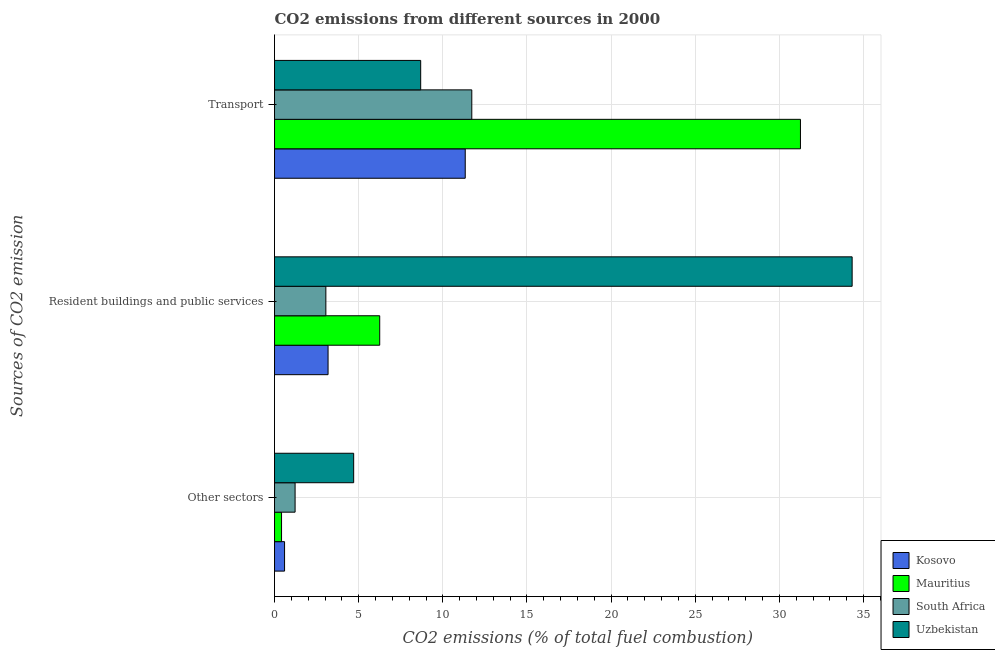How many different coloured bars are there?
Your answer should be very brief. 4. How many groups of bars are there?
Your answer should be very brief. 3. What is the label of the 3rd group of bars from the top?
Make the answer very short. Other sectors. What is the percentage of co2 emissions from transport in Uzbekistan?
Ensure brevity in your answer.  8.68. Across all countries, what is the maximum percentage of co2 emissions from transport?
Make the answer very short. 31.25. Across all countries, what is the minimum percentage of co2 emissions from transport?
Provide a short and direct response. 8.68. In which country was the percentage of co2 emissions from transport maximum?
Your response must be concise. Mauritius. In which country was the percentage of co2 emissions from transport minimum?
Offer a terse response. Uzbekistan. What is the total percentage of co2 emissions from other sectors in the graph?
Provide a succinct answer. 6.94. What is the difference between the percentage of co2 emissions from other sectors in Uzbekistan and that in Mauritius?
Give a very brief answer. 4.29. What is the difference between the percentage of co2 emissions from resident buildings and public services in Mauritius and the percentage of co2 emissions from other sectors in Kosovo?
Give a very brief answer. 5.65. What is the average percentage of co2 emissions from resident buildings and public services per country?
Give a very brief answer. 11.7. What is the difference between the percentage of co2 emissions from other sectors and percentage of co2 emissions from transport in South Africa?
Provide a short and direct response. -10.5. In how many countries, is the percentage of co2 emissions from other sectors greater than 18 %?
Make the answer very short. 0. What is the ratio of the percentage of co2 emissions from resident buildings and public services in Kosovo to that in Uzbekistan?
Give a very brief answer. 0.09. What is the difference between the highest and the second highest percentage of co2 emissions from resident buildings and public services?
Your response must be concise. 28.07. What is the difference between the highest and the lowest percentage of co2 emissions from transport?
Ensure brevity in your answer.  22.57. In how many countries, is the percentage of co2 emissions from other sectors greater than the average percentage of co2 emissions from other sectors taken over all countries?
Make the answer very short. 1. Is the sum of the percentage of co2 emissions from resident buildings and public services in Kosovo and South Africa greater than the maximum percentage of co2 emissions from transport across all countries?
Keep it short and to the point. No. What does the 1st bar from the top in Resident buildings and public services represents?
Provide a succinct answer. Uzbekistan. What does the 3rd bar from the bottom in Resident buildings and public services represents?
Keep it short and to the point. South Africa. Is it the case that in every country, the sum of the percentage of co2 emissions from other sectors and percentage of co2 emissions from resident buildings and public services is greater than the percentage of co2 emissions from transport?
Ensure brevity in your answer.  No. How many countries are there in the graph?
Give a very brief answer. 4. What is the difference between two consecutive major ticks on the X-axis?
Offer a terse response. 5. How many legend labels are there?
Provide a succinct answer. 4. How are the legend labels stacked?
Your answer should be very brief. Vertical. What is the title of the graph?
Give a very brief answer. CO2 emissions from different sources in 2000. What is the label or title of the X-axis?
Ensure brevity in your answer.  CO2 emissions (% of total fuel combustion). What is the label or title of the Y-axis?
Give a very brief answer. Sources of CO2 emission. What is the CO2 emissions (% of total fuel combustion) of Kosovo in Other sectors?
Make the answer very short. 0.6. What is the CO2 emissions (% of total fuel combustion) of Mauritius in Other sectors?
Your answer should be very brief. 0.42. What is the CO2 emissions (% of total fuel combustion) of South Africa in Other sectors?
Offer a terse response. 1.22. What is the CO2 emissions (% of total fuel combustion) of Uzbekistan in Other sectors?
Make the answer very short. 4.7. What is the CO2 emissions (% of total fuel combustion) in Kosovo in Resident buildings and public services?
Provide a succinct answer. 3.18. What is the CO2 emissions (% of total fuel combustion) in Mauritius in Resident buildings and public services?
Keep it short and to the point. 6.25. What is the CO2 emissions (% of total fuel combustion) of South Africa in Resident buildings and public services?
Make the answer very short. 3.05. What is the CO2 emissions (% of total fuel combustion) in Uzbekistan in Resident buildings and public services?
Your answer should be very brief. 34.32. What is the CO2 emissions (% of total fuel combustion) in Kosovo in Transport?
Your response must be concise. 11.33. What is the CO2 emissions (% of total fuel combustion) of Mauritius in Transport?
Provide a short and direct response. 31.25. What is the CO2 emissions (% of total fuel combustion) in South Africa in Transport?
Provide a short and direct response. 11.72. What is the CO2 emissions (% of total fuel combustion) of Uzbekistan in Transport?
Offer a terse response. 8.68. Across all Sources of CO2 emission, what is the maximum CO2 emissions (% of total fuel combustion) in Kosovo?
Keep it short and to the point. 11.33. Across all Sources of CO2 emission, what is the maximum CO2 emissions (% of total fuel combustion) of Mauritius?
Your answer should be very brief. 31.25. Across all Sources of CO2 emission, what is the maximum CO2 emissions (% of total fuel combustion) in South Africa?
Give a very brief answer. 11.72. Across all Sources of CO2 emission, what is the maximum CO2 emissions (% of total fuel combustion) of Uzbekistan?
Your response must be concise. 34.32. Across all Sources of CO2 emission, what is the minimum CO2 emissions (% of total fuel combustion) of Kosovo?
Provide a short and direct response. 0.6. Across all Sources of CO2 emission, what is the minimum CO2 emissions (% of total fuel combustion) of Mauritius?
Your response must be concise. 0.42. Across all Sources of CO2 emission, what is the minimum CO2 emissions (% of total fuel combustion) of South Africa?
Offer a very short reply. 1.22. Across all Sources of CO2 emission, what is the minimum CO2 emissions (% of total fuel combustion) of Uzbekistan?
Make the answer very short. 4.7. What is the total CO2 emissions (% of total fuel combustion) of Kosovo in the graph?
Ensure brevity in your answer.  15.11. What is the total CO2 emissions (% of total fuel combustion) of Mauritius in the graph?
Offer a terse response. 37.92. What is the total CO2 emissions (% of total fuel combustion) of South Africa in the graph?
Provide a short and direct response. 15.99. What is the total CO2 emissions (% of total fuel combustion) of Uzbekistan in the graph?
Your answer should be very brief. 47.71. What is the difference between the CO2 emissions (% of total fuel combustion) of Kosovo in Other sectors and that in Resident buildings and public services?
Offer a terse response. -2.58. What is the difference between the CO2 emissions (% of total fuel combustion) in Mauritius in Other sectors and that in Resident buildings and public services?
Make the answer very short. -5.83. What is the difference between the CO2 emissions (% of total fuel combustion) of South Africa in Other sectors and that in Resident buildings and public services?
Provide a succinct answer. -1.83. What is the difference between the CO2 emissions (% of total fuel combustion) in Uzbekistan in Other sectors and that in Resident buildings and public services?
Offer a very short reply. -29.62. What is the difference between the CO2 emissions (% of total fuel combustion) in Kosovo in Other sectors and that in Transport?
Provide a succinct answer. -10.74. What is the difference between the CO2 emissions (% of total fuel combustion) in Mauritius in Other sectors and that in Transport?
Your response must be concise. -30.83. What is the difference between the CO2 emissions (% of total fuel combustion) of South Africa in Other sectors and that in Transport?
Your answer should be compact. -10.5. What is the difference between the CO2 emissions (% of total fuel combustion) in Uzbekistan in Other sectors and that in Transport?
Your answer should be compact. -3.98. What is the difference between the CO2 emissions (% of total fuel combustion) of Kosovo in Resident buildings and public services and that in Transport?
Provide a short and direct response. -8.15. What is the difference between the CO2 emissions (% of total fuel combustion) in South Africa in Resident buildings and public services and that in Transport?
Keep it short and to the point. -8.67. What is the difference between the CO2 emissions (% of total fuel combustion) of Uzbekistan in Resident buildings and public services and that in Transport?
Provide a succinct answer. 25.64. What is the difference between the CO2 emissions (% of total fuel combustion) in Kosovo in Other sectors and the CO2 emissions (% of total fuel combustion) in Mauritius in Resident buildings and public services?
Your answer should be compact. -5.65. What is the difference between the CO2 emissions (% of total fuel combustion) of Kosovo in Other sectors and the CO2 emissions (% of total fuel combustion) of South Africa in Resident buildings and public services?
Offer a terse response. -2.45. What is the difference between the CO2 emissions (% of total fuel combustion) of Kosovo in Other sectors and the CO2 emissions (% of total fuel combustion) of Uzbekistan in Resident buildings and public services?
Your response must be concise. -33.73. What is the difference between the CO2 emissions (% of total fuel combustion) of Mauritius in Other sectors and the CO2 emissions (% of total fuel combustion) of South Africa in Resident buildings and public services?
Your response must be concise. -2.63. What is the difference between the CO2 emissions (% of total fuel combustion) in Mauritius in Other sectors and the CO2 emissions (% of total fuel combustion) in Uzbekistan in Resident buildings and public services?
Give a very brief answer. -33.91. What is the difference between the CO2 emissions (% of total fuel combustion) in South Africa in Other sectors and the CO2 emissions (% of total fuel combustion) in Uzbekistan in Resident buildings and public services?
Keep it short and to the point. -33.1. What is the difference between the CO2 emissions (% of total fuel combustion) of Kosovo in Other sectors and the CO2 emissions (% of total fuel combustion) of Mauritius in Transport?
Your answer should be compact. -30.65. What is the difference between the CO2 emissions (% of total fuel combustion) of Kosovo in Other sectors and the CO2 emissions (% of total fuel combustion) of South Africa in Transport?
Ensure brevity in your answer.  -11.13. What is the difference between the CO2 emissions (% of total fuel combustion) in Kosovo in Other sectors and the CO2 emissions (% of total fuel combustion) in Uzbekistan in Transport?
Offer a terse response. -8.09. What is the difference between the CO2 emissions (% of total fuel combustion) in Mauritius in Other sectors and the CO2 emissions (% of total fuel combustion) in South Africa in Transport?
Provide a short and direct response. -11.3. What is the difference between the CO2 emissions (% of total fuel combustion) of Mauritius in Other sectors and the CO2 emissions (% of total fuel combustion) of Uzbekistan in Transport?
Your response must be concise. -8.27. What is the difference between the CO2 emissions (% of total fuel combustion) of South Africa in Other sectors and the CO2 emissions (% of total fuel combustion) of Uzbekistan in Transport?
Your answer should be compact. -7.46. What is the difference between the CO2 emissions (% of total fuel combustion) in Kosovo in Resident buildings and public services and the CO2 emissions (% of total fuel combustion) in Mauritius in Transport?
Make the answer very short. -28.07. What is the difference between the CO2 emissions (% of total fuel combustion) of Kosovo in Resident buildings and public services and the CO2 emissions (% of total fuel combustion) of South Africa in Transport?
Provide a succinct answer. -8.54. What is the difference between the CO2 emissions (% of total fuel combustion) of Kosovo in Resident buildings and public services and the CO2 emissions (% of total fuel combustion) of Uzbekistan in Transport?
Provide a succinct answer. -5.5. What is the difference between the CO2 emissions (% of total fuel combustion) in Mauritius in Resident buildings and public services and the CO2 emissions (% of total fuel combustion) in South Africa in Transport?
Your response must be concise. -5.47. What is the difference between the CO2 emissions (% of total fuel combustion) in Mauritius in Resident buildings and public services and the CO2 emissions (% of total fuel combustion) in Uzbekistan in Transport?
Provide a short and direct response. -2.43. What is the difference between the CO2 emissions (% of total fuel combustion) of South Africa in Resident buildings and public services and the CO2 emissions (% of total fuel combustion) of Uzbekistan in Transport?
Your answer should be compact. -5.63. What is the average CO2 emissions (% of total fuel combustion) of Kosovo per Sources of CO2 emission?
Offer a very short reply. 5.04. What is the average CO2 emissions (% of total fuel combustion) of Mauritius per Sources of CO2 emission?
Your answer should be very brief. 12.64. What is the average CO2 emissions (% of total fuel combustion) of South Africa per Sources of CO2 emission?
Ensure brevity in your answer.  5.33. What is the average CO2 emissions (% of total fuel combustion) in Uzbekistan per Sources of CO2 emission?
Your response must be concise. 15.9. What is the difference between the CO2 emissions (% of total fuel combustion) of Kosovo and CO2 emissions (% of total fuel combustion) of Mauritius in Other sectors?
Your answer should be very brief. 0.18. What is the difference between the CO2 emissions (% of total fuel combustion) of Kosovo and CO2 emissions (% of total fuel combustion) of South Africa in Other sectors?
Your answer should be very brief. -0.63. What is the difference between the CO2 emissions (% of total fuel combustion) in Kosovo and CO2 emissions (% of total fuel combustion) in Uzbekistan in Other sectors?
Your response must be concise. -4.11. What is the difference between the CO2 emissions (% of total fuel combustion) of Mauritius and CO2 emissions (% of total fuel combustion) of South Africa in Other sectors?
Offer a terse response. -0.81. What is the difference between the CO2 emissions (% of total fuel combustion) of Mauritius and CO2 emissions (% of total fuel combustion) of Uzbekistan in Other sectors?
Offer a terse response. -4.29. What is the difference between the CO2 emissions (% of total fuel combustion) of South Africa and CO2 emissions (% of total fuel combustion) of Uzbekistan in Other sectors?
Your answer should be compact. -3.48. What is the difference between the CO2 emissions (% of total fuel combustion) of Kosovo and CO2 emissions (% of total fuel combustion) of Mauritius in Resident buildings and public services?
Give a very brief answer. -3.07. What is the difference between the CO2 emissions (% of total fuel combustion) of Kosovo and CO2 emissions (% of total fuel combustion) of South Africa in Resident buildings and public services?
Offer a very short reply. 0.13. What is the difference between the CO2 emissions (% of total fuel combustion) in Kosovo and CO2 emissions (% of total fuel combustion) in Uzbekistan in Resident buildings and public services?
Provide a succinct answer. -31.14. What is the difference between the CO2 emissions (% of total fuel combustion) of Mauritius and CO2 emissions (% of total fuel combustion) of South Africa in Resident buildings and public services?
Make the answer very short. 3.2. What is the difference between the CO2 emissions (% of total fuel combustion) in Mauritius and CO2 emissions (% of total fuel combustion) in Uzbekistan in Resident buildings and public services?
Provide a succinct answer. -28.07. What is the difference between the CO2 emissions (% of total fuel combustion) in South Africa and CO2 emissions (% of total fuel combustion) in Uzbekistan in Resident buildings and public services?
Ensure brevity in your answer.  -31.27. What is the difference between the CO2 emissions (% of total fuel combustion) of Kosovo and CO2 emissions (% of total fuel combustion) of Mauritius in Transport?
Your answer should be compact. -19.92. What is the difference between the CO2 emissions (% of total fuel combustion) in Kosovo and CO2 emissions (% of total fuel combustion) in South Africa in Transport?
Offer a terse response. -0.39. What is the difference between the CO2 emissions (% of total fuel combustion) of Kosovo and CO2 emissions (% of total fuel combustion) of Uzbekistan in Transport?
Your answer should be compact. 2.65. What is the difference between the CO2 emissions (% of total fuel combustion) of Mauritius and CO2 emissions (% of total fuel combustion) of South Africa in Transport?
Make the answer very short. 19.53. What is the difference between the CO2 emissions (% of total fuel combustion) of Mauritius and CO2 emissions (% of total fuel combustion) of Uzbekistan in Transport?
Keep it short and to the point. 22.57. What is the difference between the CO2 emissions (% of total fuel combustion) of South Africa and CO2 emissions (% of total fuel combustion) of Uzbekistan in Transport?
Offer a very short reply. 3.04. What is the ratio of the CO2 emissions (% of total fuel combustion) in Kosovo in Other sectors to that in Resident buildings and public services?
Make the answer very short. 0.19. What is the ratio of the CO2 emissions (% of total fuel combustion) of Mauritius in Other sectors to that in Resident buildings and public services?
Give a very brief answer. 0.07. What is the ratio of the CO2 emissions (% of total fuel combustion) in South Africa in Other sectors to that in Resident buildings and public services?
Offer a very short reply. 0.4. What is the ratio of the CO2 emissions (% of total fuel combustion) of Uzbekistan in Other sectors to that in Resident buildings and public services?
Provide a short and direct response. 0.14. What is the ratio of the CO2 emissions (% of total fuel combustion) of Kosovo in Other sectors to that in Transport?
Give a very brief answer. 0.05. What is the ratio of the CO2 emissions (% of total fuel combustion) in Mauritius in Other sectors to that in Transport?
Ensure brevity in your answer.  0.01. What is the ratio of the CO2 emissions (% of total fuel combustion) in South Africa in Other sectors to that in Transport?
Your answer should be very brief. 0.1. What is the ratio of the CO2 emissions (% of total fuel combustion) in Uzbekistan in Other sectors to that in Transport?
Offer a terse response. 0.54. What is the ratio of the CO2 emissions (% of total fuel combustion) of Kosovo in Resident buildings and public services to that in Transport?
Your answer should be compact. 0.28. What is the ratio of the CO2 emissions (% of total fuel combustion) in Mauritius in Resident buildings and public services to that in Transport?
Offer a terse response. 0.2. What is the ratio of the CO2 emissions (% of total fuel combustion) in South Africa in Resident buildings and public services to that in Transport?
Your answer should be very brief. 0.26. What is the ratio of the CO2 emissions (% of total fuel combustion) of Uzbekistan in Resident buildings and public services to that in Transport?
Offer a terse response. 3.95. What is the difference between the highest and the second highest CO2 emissions (% of total fuel combustion) in Kosovo?
Provide a short and direct response. 8.15. What is the difference between the highest and the second highest CO2 emissions (% of total fuel combustion) of South Africa?
Your answer should be compact. 8.67. What is the difference between the highest and the second highest CO2 emissions (% of total fuel combustion) of Uzbekistan?
Make the answer very short. 25.64. What is the difference between the highest and the lowest CO2 emissions (% of total fuel combustion) in Kosovo?
Give a very brief answer. 10.74. What is the difference between the highest and the lowest CO2 emissions (% of total fuel combustion) of Mauritius?
Make the answer very short. 30.83. What is the difference between the highest and the lowest CO2 emissions (% of total fuel combustion) of South Africa?
Your answer should be very brief. 10.5. What is the difference between the highest and the lowest CO2 emissions (% of total fuel combustion) of Uzbekistan?
Your response must be concise. 29.62. 